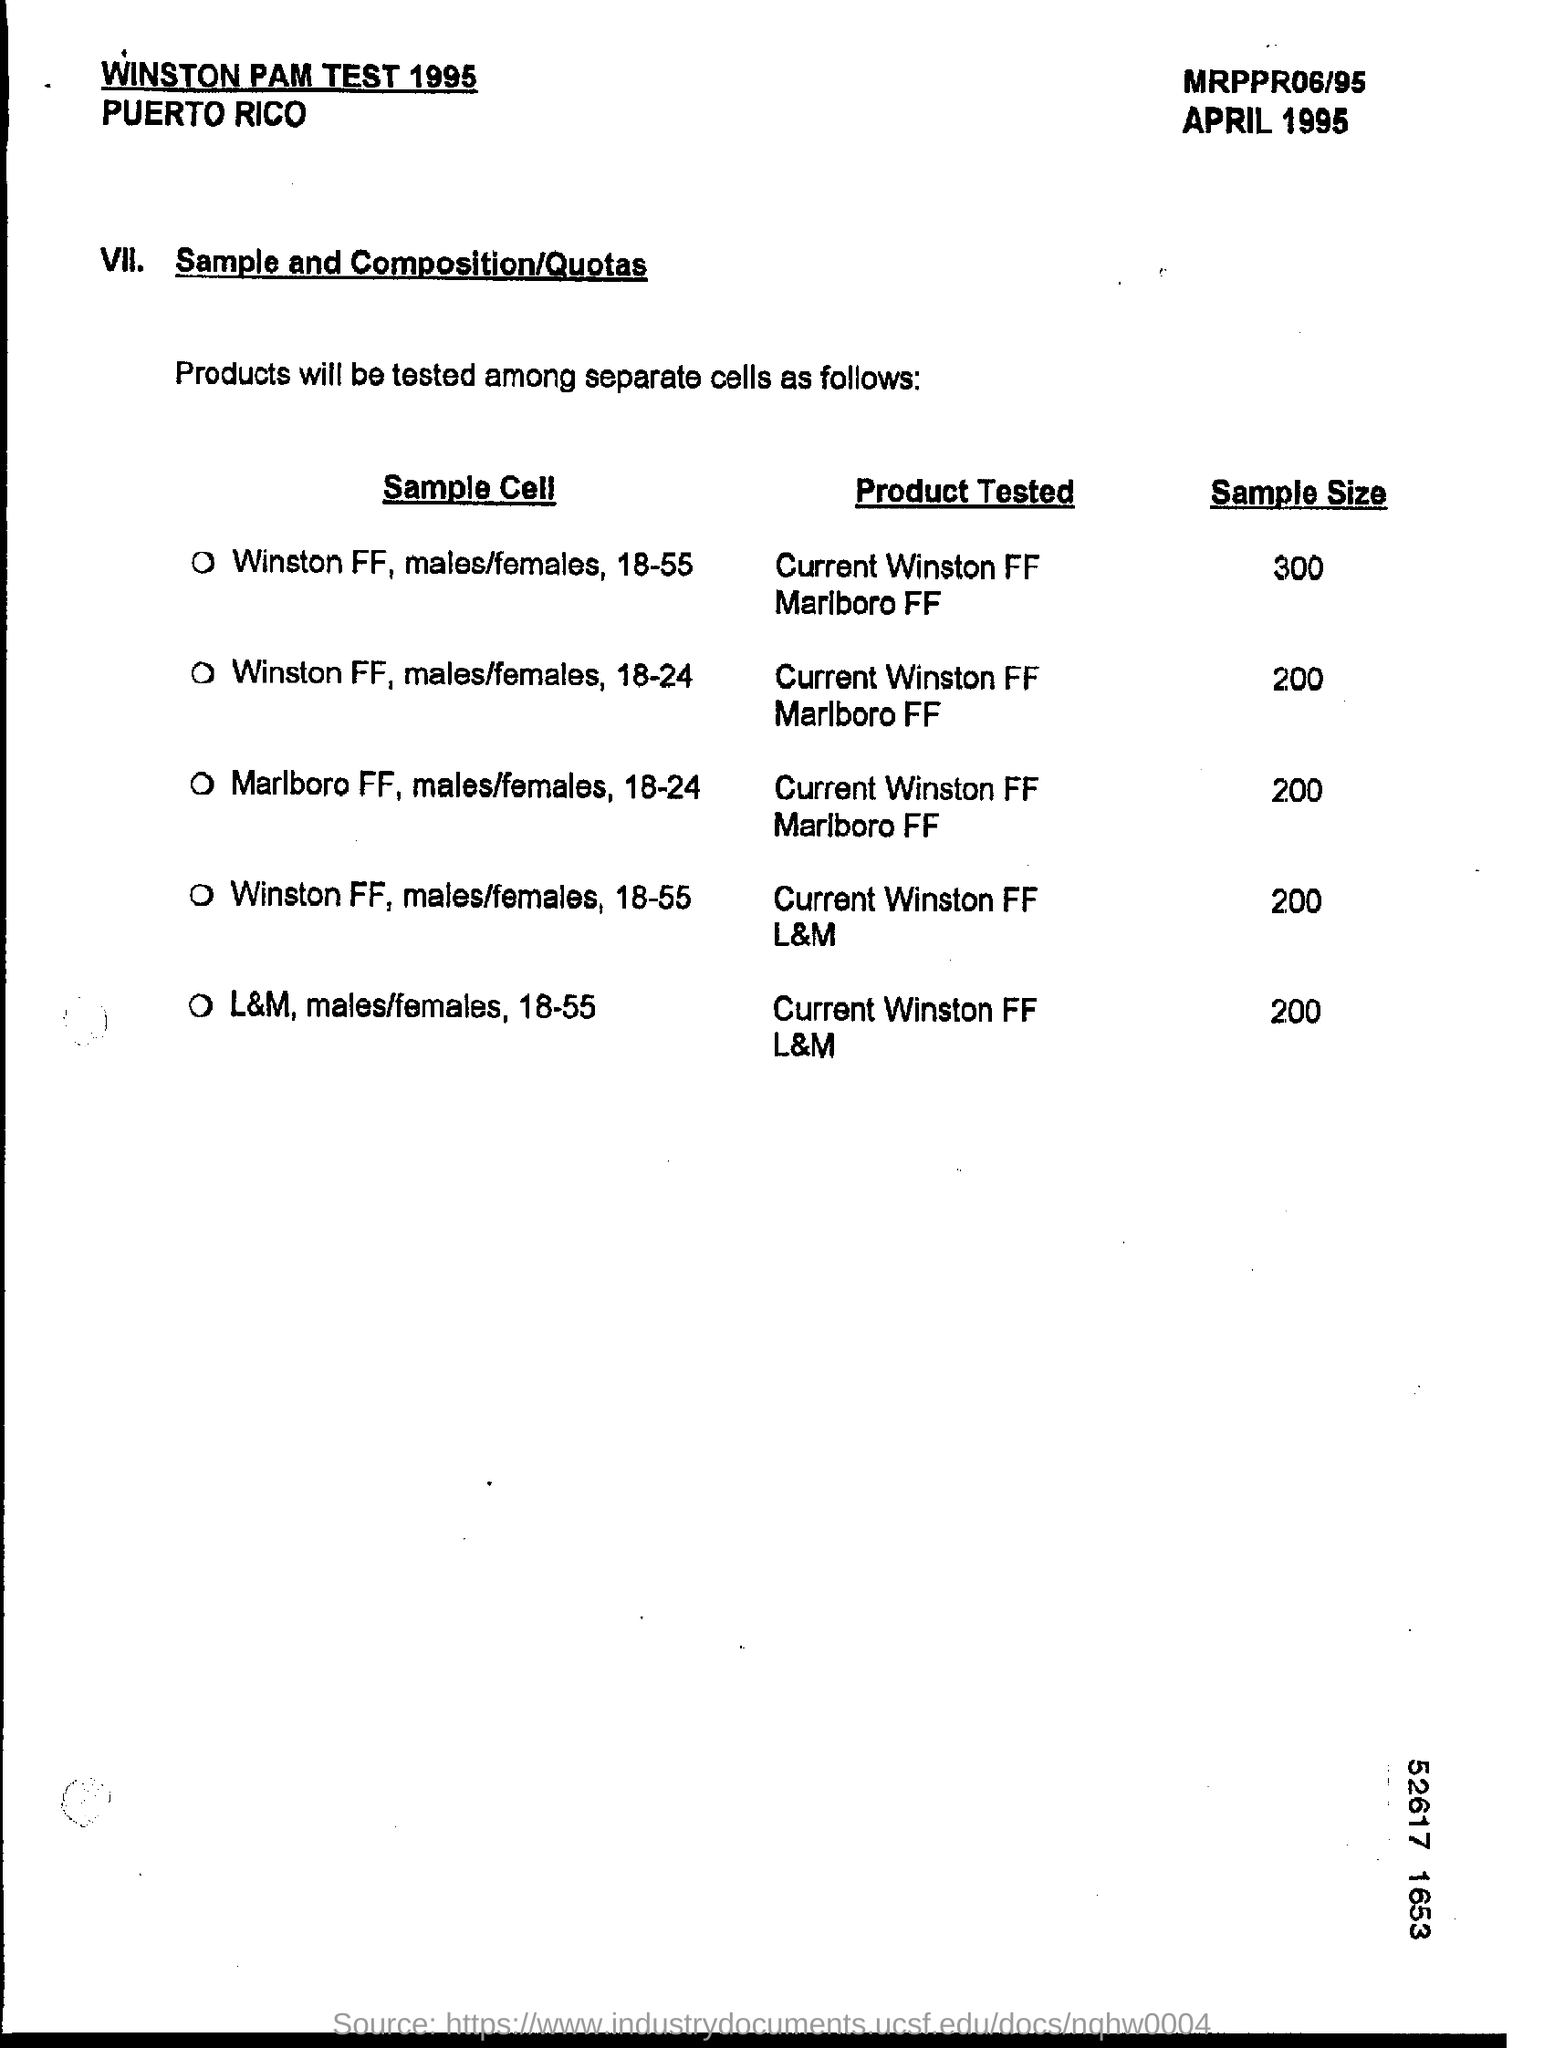What is the sample size for product tested "current winston ff l&m" ?
Give a very brief answer. 200. 